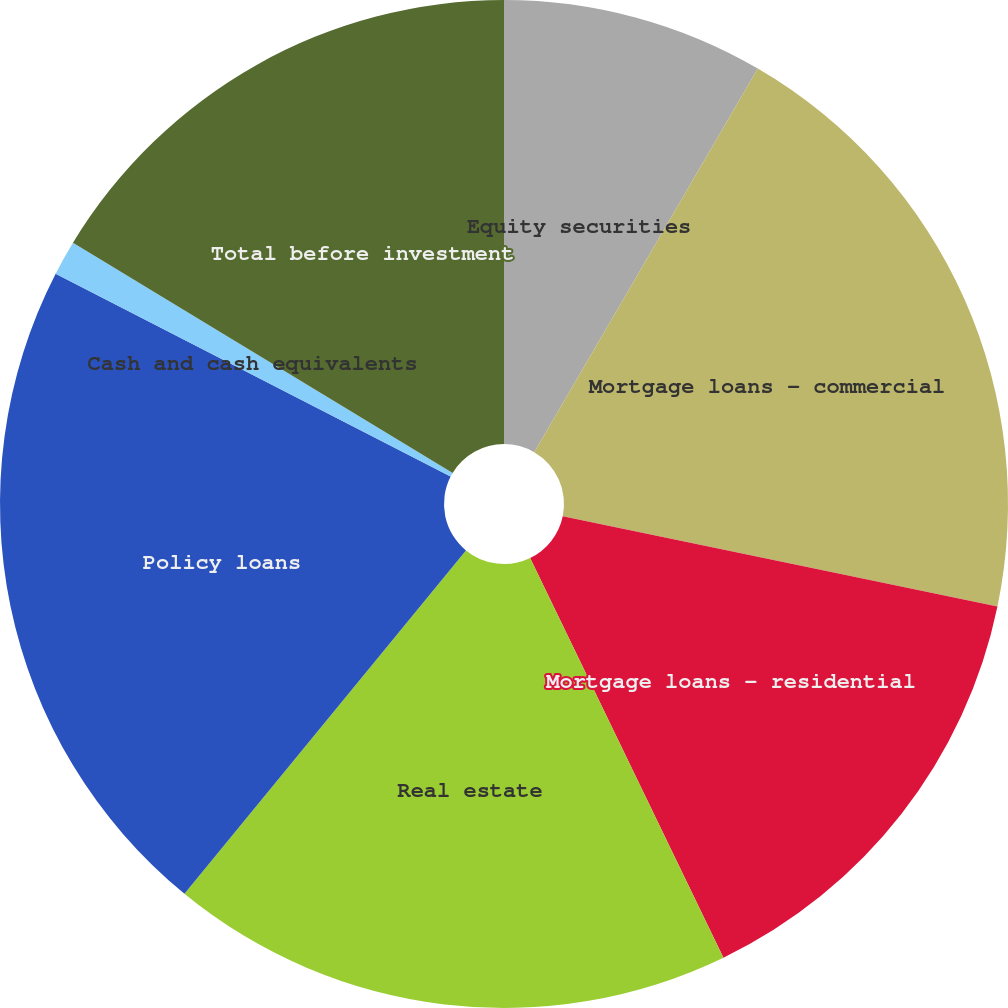Convert chart. <chart><loc_0><loc_0><loc_500><loc_500><pie_chart><fcel>Equity securities<fcel>Mortgage loans - commercial<fcel>Mortgage loans - residential<fcel>Real estate<fcel>Policy loans<fcel>Cash and cash equivalents<fcel>Total before investment<nl><fcel>8.4%<fcel>19.86%<fcel>14.57%<fcel>18.1%<fcel>21.62%<fcel>1.12%<fcel>16.33%<nl></chart> 